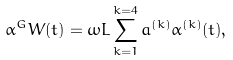Convert formula to latex. <formula><loc_0><loc_0><loc_500><loc_500>\alpha ^ { G } W ( t ) = \omega L \sum _ { k = 1 } ^ { k = 4 } a ^ { ( k ) } \alpha ^ { ( k ) } ( t ) ,</formula> 